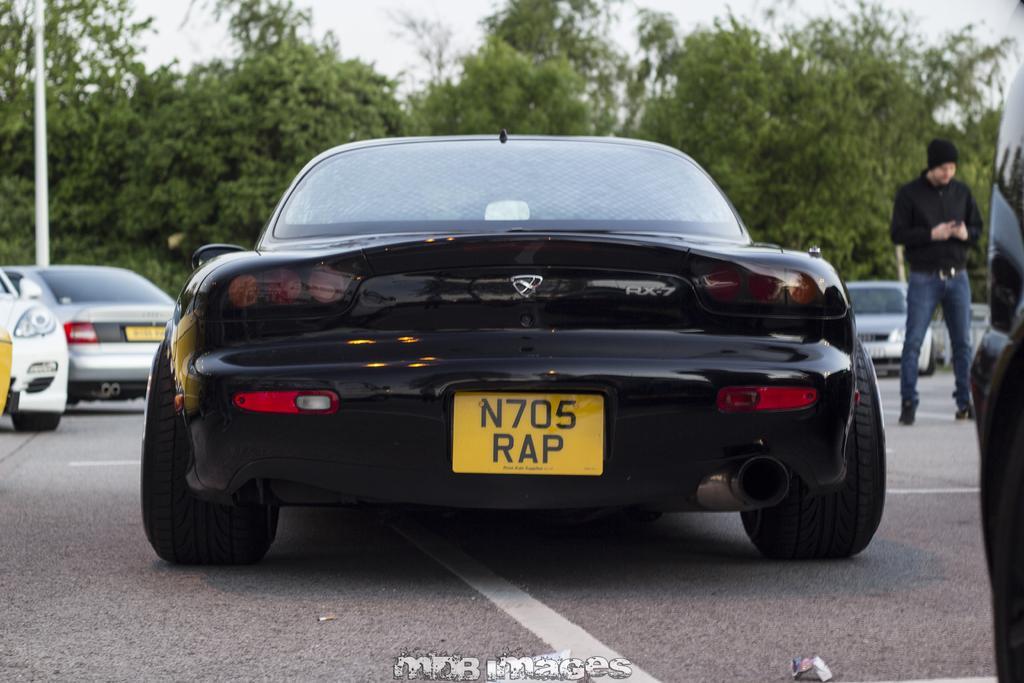Please provide a concise description of this image. As we can see in the image there are cars, trees, a person wearing black color jacket and there is sky. 